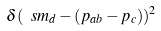Convert formula to latex. <formula><loc_0><loc_0><loc_500><loc_500>\delta ( \ s m _ { d } - ( p _ { a b } - p _ { c } ) ) ^ { 2 }</formula> 